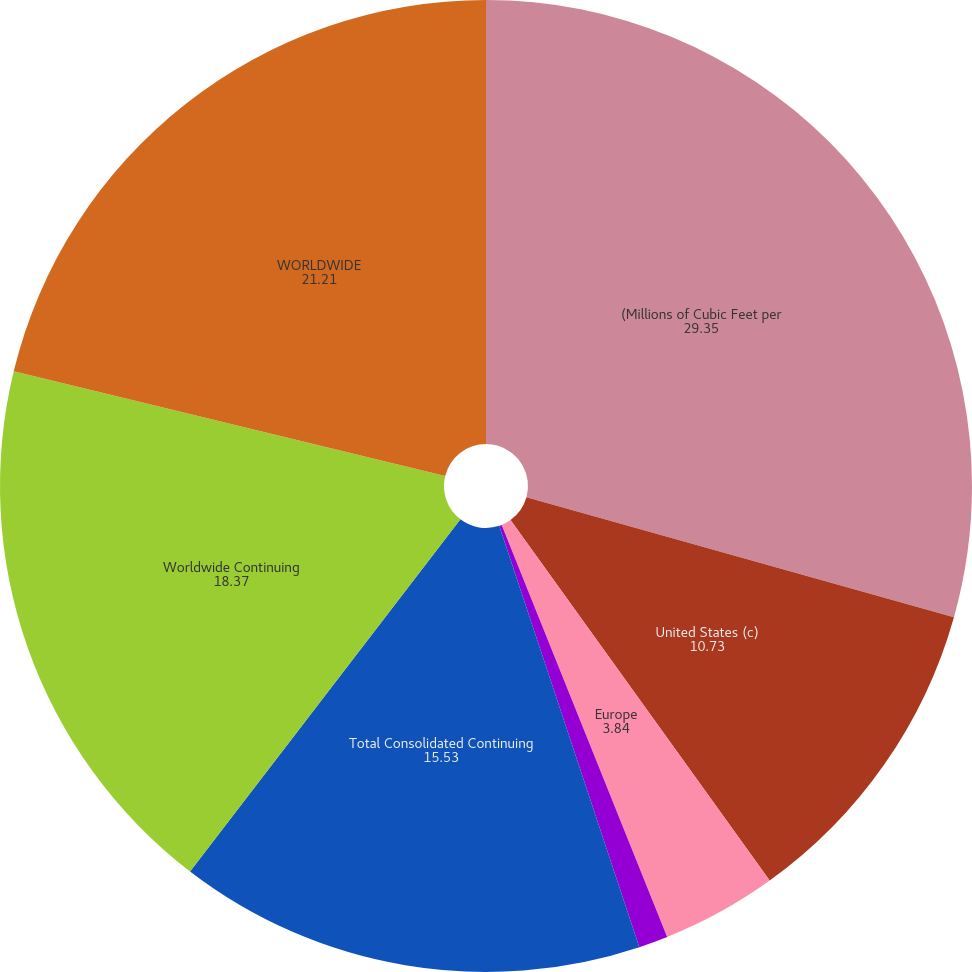<chart> <loc_0><loc_0><loc_500><loc_500><pie_chart><fcel>(Millions of Cubic Feet per<fcel>United States (c)<fcel>Europe<fcel>West Africa<fcel>Total Consolidated Continuing<fcel>Worldwide Continuing<fcel>WORLDWIDE<nl><fcel>29.35%<fcel>10.73%<fcel>3.84%<fcel>0.97%<fcel>15.53%<fcel>18.37%<fcel>21.21%<nl></chart> 